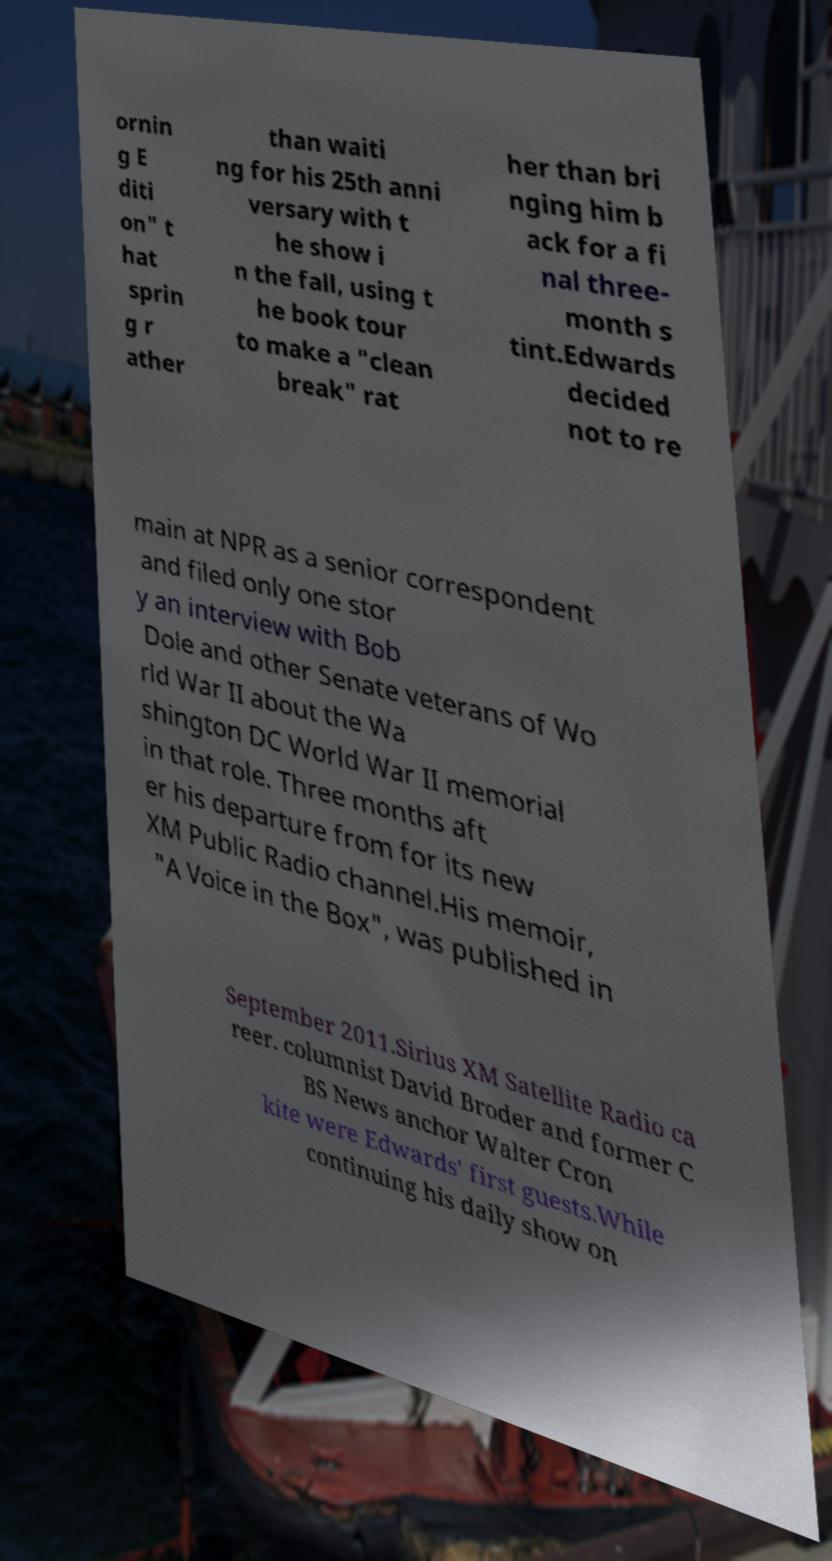Can you accurately transcribe the text from the provided image for me? ornin g E diti on" t hat sprin g r ather than waiti ng for his 25th anni versary with t he show i n the fall, using t he book tour to make a "clean break" rat her than bri nging him b ack for a fi nal three- month s tint.Edwards decided not to re main at NPR as a senior correspondent and filed only one stor y an interview with Bob Dole and other Senate veterans of Wo rld War II about the Wa shington DC World War II memorial in that role. Three months aft er his departure from for its new XM Public Radio channel.His memoir, "A Voice in the Box", was published in September 2011.Sirius XM Satellite Radio ca reer. columnist David Broder and former C BS News anchor Walter Cron kite were Edwards' first guests.While continuing his daily show on 